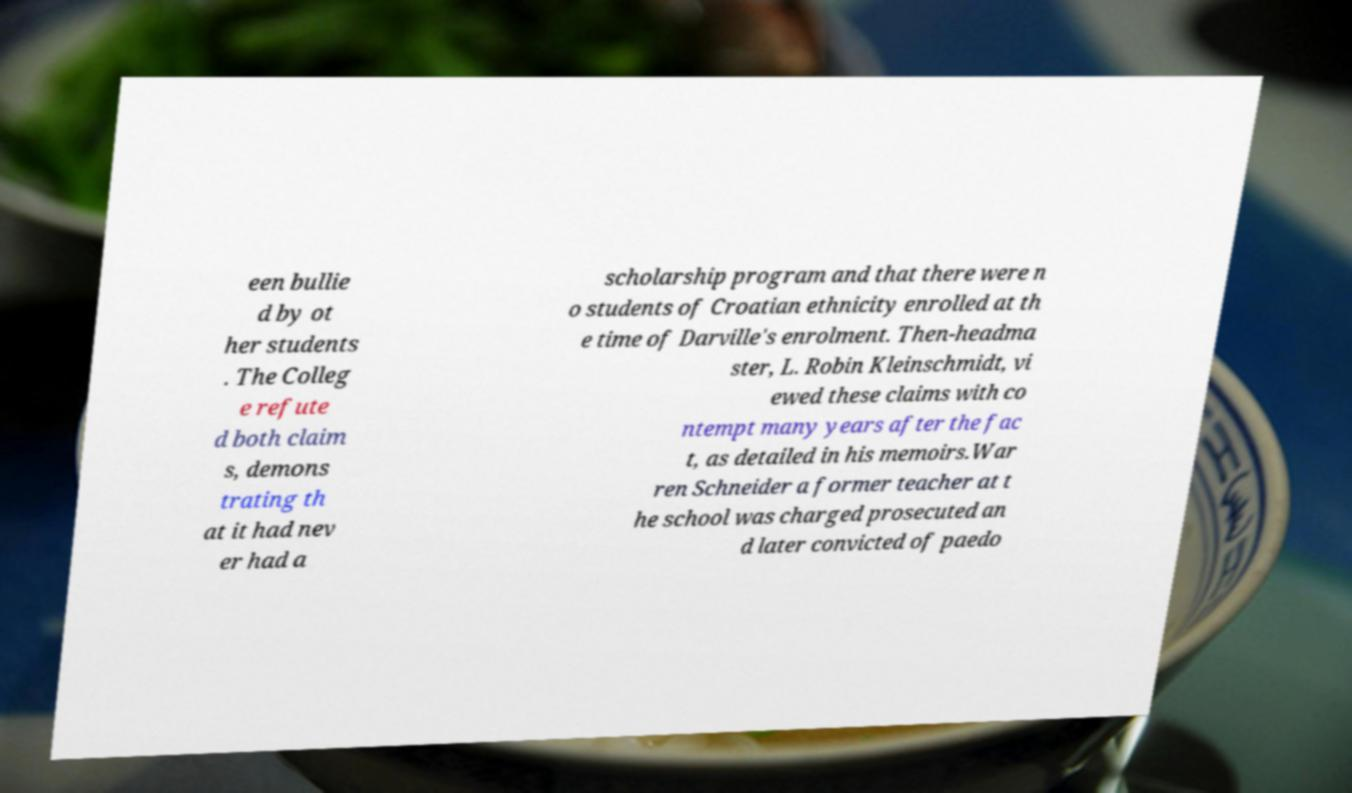Please identify and transcribe the text found in this image. een bullie d by ot her students . The Colleg e refute d both claim s, demons trating th at it had nev er had a scholarship program and that there were n o students of Croatian ethnicity enrolled at th e time of Darville's enrolment. Then-headma ster, L. Robin Kleinschmidt, vi ewed these claims with co ntempt many years after the fac t, as detailed in his memoirs.War ren Schneider a former teacher at t he school was charged prosecuted an d later convicted of paedo 